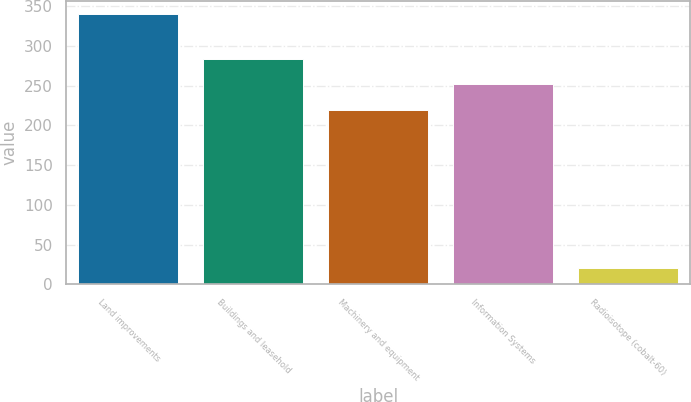<chart> <loc_0><loc_0><loc_500><loc_500><bar_chart><fcel>Land improvements<fcel>Buildings and leasehold<fcel>Machinery and equipment<fcel>Information Systems<fcel>Radioisotope (cobalt-60)<nl><fcel>340<fcel>284<fcel>220<fcel>252<fcel>20<nl></chart> 